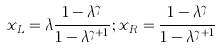Convert formula to latex. <formula><loc_0><loc_0><loc_500><loc_500>x _ { L } = \lambda \frac { 1 - \lambda ^ { \gamma } } { 1 - \lambda ^ { \gamma + 1 } } ; x _ { R } = \frac { 1 - \lambda ^ { \gamma } } { 1 - \lambda ^ { \gamma + 1 } }</formula> 